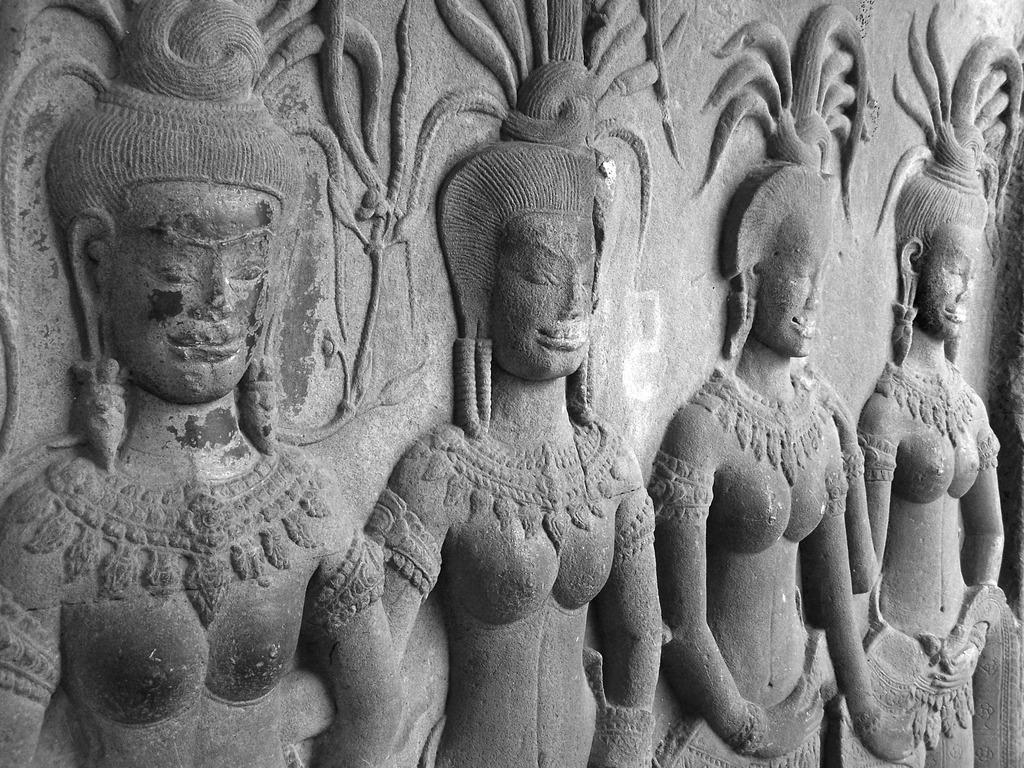What type of objects can be seen in the image? There are statues in the image. What color are the statues? The statues are in gray color. Are there any toys performing magic tricks with their brother in the image? No, there are no toys or any indication of magic tricks or a brother in the image; it features statues in gray color. 